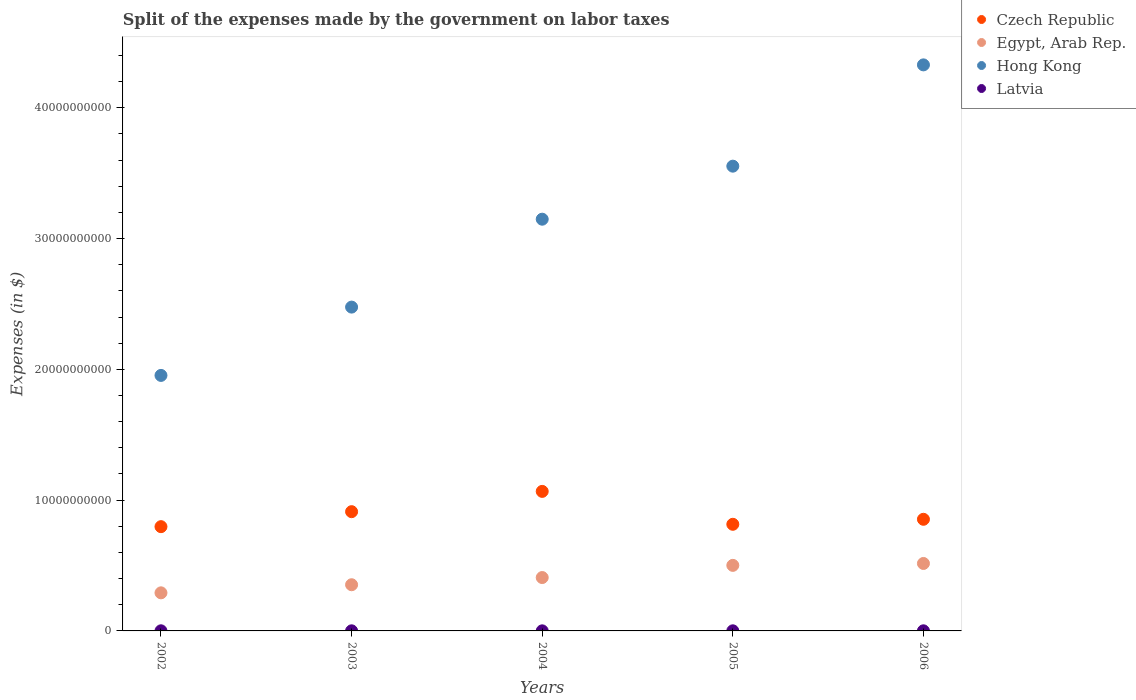What is the expenses made by the government on labor taxes in Egypt, Arab Rep. in 2005?
Give a very brief answer. 5.01e+09. Across all years, what is the maximum expenses made by the government on labor taxes in Czech Republic?
Make the answer very short. 1.07e+1. Across all years, what is the minimum expenses made by the government on labor taxes in Czech Republic?
Your answer should be very brief. 7.97e+09. In which year was the expenses made by the government on labor taxes in Latvia maximum?
Your answer should be very brief. 2002. In which year was the expenses made by the government on labor taxes in Hong Kong minimum?
Your response must be concise. 2002. What is the total expenses made by the government on labor taxes in Czech Republic in the graph?
Offer a very short reply. 4.44e+1. What is the difference between the expenses made by the government on labor taxes in Latvia in 2002 and the expenses made by the government on labor taxes in Egypt, Arab Rep. in 2005?
Your answer should be compact. -5.00e+09. What is the average expenses made by the government on labor taxes in Egypt, Arab Rep. per year?
Give a very brief answer. 4.14e+09. In the year 2002, what is the difference between the expenses made by the government on labor taxes in Czech Republic and expenses made by the government on labor taxes in Latvia?
Provide a succinct answer. 7.96e+09. In how many years, is the expenses made by the government on labor taxes in Egypt, Arab Rep. greater than 22000000000 $?
Give a very brief answer. 0. What is the ratio of the expenses made by the government on labor taxes in Latvia in 2003 to that in 2004?
Offer a very short reply. 1.28. Is the expenses made by the government on labor taxes in Latvia in 2004 less than that in 2006?
Your answer should be very brief. Yes. What is the difference between the highest and the second highest expenses made by the government on labor taxes in Czech Republic?
Make the answer very short. 1.55e+09. What is the difference between the highest and the lowest expenses made by the government on labor taxes in Latvia?
Offer a terse response. 2.50e+06. In how many years, is the expenses made by the government on labor taxes in Latvia greater than the average expenses made by the government on labor taxes in Latvia taken over all years?
Offer a terse response. 3. Is the sum of the expenses made by the government on labor taxes in Czech Republic in 2003 and 2005 greater than the maximum expenses made by the government on labor taxes in Hong Kong across all years?
Offer a terse response. No. Is it the case that in every year, the sum of the expenses made by the government on labor taxes in Czech Republic and expenses made by the government on labor taxes in Latvia  is greater than the sum of expenses made by the government on labor taxes in Hong Kong and expenses made by the government on labor taxes in Egypt, Arab Rep.?
Your answer should be very brief. Yes. Is it the case that in every year, the sum of the expenses made by the government on labor taxes in Czech Republic and expenses made by the government on labor taxes in Hong Kong  is greater than the expenses made by the government on labor taxes in Egypt, Arab Rep.?
Keep it short and to the point. Yes. Does the expenses made by the government on labor taxes in Egypt, Arab Rep. monotonically increase over the years?
Make the answer very short. Yes. How many dotlines are there?
Offer a very short reply. 4. How many years are there in the graph?
Give a very brief answer. 5. What is the difference between two consecutive major ticks on the Y-axis?
Offer a terse response. 1.00e+1. Does the graph contain any zero values?
Keep it short and to the point. No. Does the graph contain grids?
Provide a short and direct response. No. How are the legend labels stacked?
Your answer should be compact. Vertical. What is the title of the graph?
Offer a terse response. Split of the expenses made by the government on labor taxes. Does "Gabon" appear as one of the legend labels in the graph?
Provide a short and direct response. No. What is the label or title of the Y-axis?
Offer a very short reply. Expenses (in $). What is the Expenses (in $) in Czech Republic in 2002?
Offer a terse response. 7.97e+09. What is the Expenses (in $) in Egypt, Arab Rep. in 2002?
Provide a short and direct response. 2.91e+09. What is the Expenses (in $) of Hong Kong in 2002?
Offer a very short reply. 1.95e+1. What is the Expenses (in $) of Latvia in 2002?
Your answer should be very brief. 8.60e+06. What is the Expenses (in $) in Czech Republic in 2003?
Your answer should be very brief. 9.12e+09. What is the Expenses (in $) in Egypt, Arab Rep. in 2003?
Provide a succinct answer. 3.53e+09. What is the Expenses (in $) of Hong Kong in 2003?
Your response must be concise. 2.48e+1. What is the Expenses (in $) in Latvia in 2003?
Give a very brief answer. 7.80e+06. What is the Expenses (in $) in Czech Republic in 2004?
Your answer should be compact. 1.07e+1. What is the Expenses (in $) of Egypt, Arab Rep. in 2004?
Your response must be concise. 4.08e+09. What is the Expenses (in $) of Hong Kong in 2004?
Your response must be concise. 3.15e+1. What is the Expenses (in $) of Latvia in 2004?
Your response must be concise. 6.10e+06. What is the Expenses (in $) in Czech Republic in 2005?
Provide a short and direct response. 8.15e+09. What is the Expenses (in $) of Egypt, Arab Rep. in 2005?
Ensure brevity in your answer.  5.01e+09. What is the Expenses (in $) of Hong Kong in 2005?
Provide a short and direct response. 3.55e+1. What is the Expenses (in $) in Latvia in 2005?
Give a very brief answer. 8.10e+06. What is the Expenses (in $) in Czech Republic in 2006?
Make the answer very short. 8.54e+09. What is the Expenses (in $) of Egypt, Arab Rep. in 2006?
Keep it short and to the point. 5.16e+09. What is the Expenses (in $) of Hong Kong in 2006?
Your answer should be very brief. 4.33e+1. What is the Expenses (in $) in Latvia in 2006?
Your answer should be compact. 8.40e+06. Across all years, what is the maximum Expenses (in $) of Czech Republic?
Provide a succinct answer. 1.07e+1. Across all years, what is the maximum Expenses (in $) of Egypt, Arab Rep.?
Offer a terse response. 5.16e+09. Across all years, what is the maximum Expenses (in $) in Hong Kong?
Ensure brevity in your answer.  4.33e+1. Across all years, what is the maximum Expenses (in $) in Latvia?
Keep it short and to the point. 8.60e+06. Across all years, what is the minimum Expenses (in $) in Czech Republic?
Keep it short and to the point. 7.97e+09. Across all years, what is the minimum Expenses (in $) in Egypt, Arab Rep.?
Offer a very short reply. 2.91e+09. Across all years, what is the minimum Expenses (in $) of Hong Kong?
Provide a short and direct response. 1.95e+1. Across all years, what is the minimum Expenses (in $) of Latvia?
Offer a very short reply. 6.10e+06. What is the total Expenses (in $) of Czech Republic in the graph?
Give a very brief answer. 4.44e+1. What is the total Expenses (in $) in Egypt, Arab Rep. in the graph?
Offer a terse response. 2.07e+1. What is the total Expenses (in $) of Hong Kong in the graph?
Provide a short and direct response. 1.55e+11. What is the total Expenses (in $) in Latvia in the graph?
Offer a very short reply. 3.90e+07. What is the difference between the Expenses (in $) of Czech Republic in 2002 and that in 2003?
Give a very brief answer. -1.15e+09. What is the difference between the Expenses (in $) of Egypt, Arab Rep. in 2002 and that in 2003?
Ensure brevity in your answer.  -6.19e+08. What is the difference between the Expenses (in $) of Hong Kong in 2002 and that in 2003?
Give a very brief answer. -5.22e+09. What is the difference between the Expenses (in $) of Latvia in 2002 and that in 2003?
Make the answer very short. 8.00e+05. What is the difference between the Expenses (in $) in Czech Republic in 2002 and that in 2004?
Ensure brevity in your answer.  -2.70e+09. What is the difference between the Expenses (in $) of Egypt, Arab Rep. in 2002 and that in 2004?
Keep it short and to the point. -1.17e+09. What is the difference between the Expenses (in $) in Hong Kong in 2002 and that in 2004?
Give a very brief answer. -1.19e+1. What is the difference between the Expenses (in $) of Latvia in 2002 and that in 2004?
Keep it short and to the point. 2.50e+06. What is the difference between the Expenses (in $) of Czech Republic in 2002 and that in 2005?
Keep it short and to the point. -1.81e+08. What is the difference between the Expenses (in $) in Egypt, Arab Rep. in 2002 and that in 2005?
Keep it short and to the point. -2.10e+09. What is the difference between the Expenses (in $) of Hong Kong in 2002 and that in 2005?
Give a very brief answer. -1.60e+1. What is the difference between the Expenses (in $) in Czech Republic in 2002 and that in 2006?
Your answer should be very brief. -5.64e+08. What is the difference between the Expenses (in $) of Egypt, Arab Rep. in 2002 and that in 2006?
Offer a very short reply. -2.25e+09. What is the difference between the Expenses (in $) of Hong Kong in 2002 and that in 2006?
Your response must be concise. -2.37e+1. What is the difference between the Expenses (in $) of Czech Republic in 2003 and that in 2004?
Ensure brevity in your answer.  -1.55e+09. What is the difference between the Expenses (in $) in Egypt, Arab Rep. in 2003 and that in 2004?
Your answer should be very brief. -5.50e+08. What is the difference between the Expenses (in $) of Hong Kong in 2003 and that in 2004?
Ensure brevity in your answer.  -6.72e+09. What is the difference between the Expenses (in $) of Latvia in 2003 and that in 2004?
Make the answer very short. 1.70e+06. What is the difference between the Expenses (in $) of Czech Republic in 2003 and that in 2005?
Give a very brief answer. 9.65e+08. What is the difference between the Expenses (in $) in Egypt, Arab Rep. in 2003 and that in 2005?
Give a very brief answer. -1.48e+09. What is the difference between the Expenses (in $) of Hong Kong in 2003 and that in 2005?
Give a very brief answer. -1.08e+1. What is the difference between the Expenses (in $) in Latvia in 2003 and that in 2005?
Provide a succinct answer. -3.00e+05. What is the difference between the Expenses (in $) of Czech Republic in 2003 and that in 2006?
Offer a very short reply. 5.82e+08. What is the difference between the Expenses (in $) in Egypt, Arab Rep. in 2003 and that in 2006?
Your answer should be compact. -1.63e+09. What is the difference between the Expenses (in $) in Hong Kong in 2003 and that in 2006?
Offer a very short reply. -1.85e+1. What is the difference between the Expenses (in $) of Latvia in 2003 and that in 2006?
Offer a very short reply. -6.00e+05. What is the difference between the Expenses (in $) of Czech Republic in 2004 and that in 2005?
Give a very brief answer. 2.52e+09. What is the difference between the Expenses (in $) of Egypt, Arab Rep. in 2004 and that in 2005?
Your answer should be compact. -9.31e+08. What is the difference between the Expenses (in $) in Hong Kong in 2004 and that in 2005?
Give a very brief answer. -4.06e+09. What is the difference between the Expenses (in $) of Czech Republic in 2004 and that in 2006?
Offer a terse response. 2.13e+09. What is the difference between the Expenses (in $) in Egypt, Arab Rep. in 2004 and that in 2006?
Give a very brief answer. -1.08e+09. What is the difference between the Expenses (in $) in Hong Kong in 2004 and that in 2006?
Your answer should be very brief. -1.18e+1. What is the difference between the Expenses (in $) in Latvia in 2004 and that in 2006?
Offer a terse response. -2.30e+06. What is the difference between the Expenses (in $) of Czech Republic in 2005 and that in 2006?
Make the answer very short. -3.83e+08. What is the difference between the Expenses (in $) in Egypt, Arab Rep. in 2005 and that in 2006?
Ensure brevity in your answer.  -1.46e+08. What is the difference between the Expenses (in $) of Hong Kong in 2005 and that in 2006?
Your answer should be very brief. -7.74e+09. What is the difference between the Expenses (in $) of Czech Republic in 2002 and the Expenses (in $) of Egypt, Arab Rep. in 2003?
Your response must be concise. 4.44e+09. What is the difference between the Expenses (in $) of Czech Republic in 2002 and the Expenses (in $) of Hong Kong in 2003?
Your answer should be compact. -1.68e+1. What is the difference between the Expenses (in $) of Czech Republic in 2002 and the Expenses (in $) of Latvia in 2003?
Provide a short and direct response. 7.96e+09. What is the difference between the Expenses (in $) in Egypt, Arab Rep. in 2002 and the Expenses (in $) in Hong Kong in 2003?
Make the answer very short. -2.18e+1. What is the difference between the Expenses (in $) of Egypt, Arab Rep. in 2002 and the Expenses (in $) of Latvia in 2003?
Ensure brevity in your answer.  2.90e+09. What is the difference between the Expenses (in $) in Hong Kong in 2002 and the Expenses (in $) in Latvia in 2003?
Ensure brevity in your answer.  1.95e+1. What is the difference between the Expenses (in $) in Czech Republic in 2002 and the Expenses (in $) in Egypt, Arab Rep. in 2004?
Provide a short and direct response. 3.89e+09. What is the difference between the Expenses (in $) of Czech Republic in 2002 and the Expenses (in $) of Hong Kong in 2004?
Your answer should be compact. -2.35e+1. What is the difference between the Expenses (in $) of Czech Republic in 2002 and the Expenses (in $) of Latvia in 2004?
Keep it short and to the point. 7.97e+09. What is the difference between the Expenses (in $) of Egypt, Arab Rep. in 2002 and the Expenses (in $) of Hong Kong in 2004?
Make the answer very short. -2.86e+1. What is the difference between the Expenses (in $) in Egypt, Arab Rep. in 2002 and the Expenses (in $) in Latvia in 2004?
Keep it short and to the point. 2.91e+09. What is the difference between the Expenses (in $) in Hong Kong in 2002 and the Expenses (in $) in Latvia in 2004?
Ensure brevity in your answer.  1.95e+1. What is the difference between the Expenses (in $) in Czech Republic in 2002 and the Expenses (in $) in Egypt, Arab Rep. in 2005?
Keep it short and to the point. 2.96e+09. What is the difference between the Expenses (in $) in Czech Republic in 2002 and the Expenses (in $) in Hong Kong in 2005?
Your answer should be compact. -2.76e+1. What is the difference between the Expenses (in $) in Czech Republic in 2002 and the Expenses (in $) in Latvia in 2005?
Offer a terse response. 7.96e+09. What is the difference between the Expenses (in $) in Egypt, Arab Rep. in 2002 and the Expenses (in $) in Hong Kong in 2005?
Give a very brief answer. -3.26e+1. What is the difference between the Expenses (in $) in Egypt, Arab Rep. in 2002 and the Expenses (in $) in Latvia in 2005?
Offer a very short reply. 2.90e+09. What is the difference between the Expenses (in $) in Hong Kong in 2002 and the Expenses (in $) in Latvia in 2005?
Your response must be concise. 1.95e+1. What is the difference between the Expenses (in $) in Czech Republic in 2002 and the Expenses (in $) in Egypt, Arab Rep. in 2006?
Provide a succinct answer. 2.81e+09. What is the difference between the Expenses (in $) of Czech Republic in 2002 and the Expenses (in $) of Hong Kong in 2006?
Provide a short and direct response. -3.53e+1. What is the difference between the Expenses (in $) of Czech Republic in 2002 and the Expenses (in $) of Latvia in 2006?
Provide a short and direct response. 7.96e+09. What is the difference between the Expenses (in $) of Egypt, Arab Rep. in 2002 and the Expenses (in $) of Hong Kong in 2006?
Ensure brevity in your answer.  -4.04e+1. What is the difference between the Expenses (in $) of Egypt, Arab Rep. in 2002 and the Expenses (in $) of Latvia in 2006?
Make the answer very short. 2.90e+09. What is the difference between the Expenses (in $) in Hong Kong in 2002 and the Expenses (in $) in Latvia in 2006?
Offer a very short reply. 1.95e+1. What is the difference between the Expenses (in $) in Czech Republic in 2003 and the Expenses (in $) in Egypt, Arab Rep. in 2004?
Offer a very short reply. 5.04e+09. What is the difference between the Expenses (in $) of Czech Republic in 2003 and the Expenses (in $) of Hong Kong in 2004?
Provide a succinct answer. -2.24e+1. What is the difference between the Expenses (in $) of Czech Republic in 2003 and the Expenses (in $) of Latvia in 2004?
Give a very brief answer. 9.11e+09. What is the difference between the Expenses (in $) of Egypt, Arab Rep. in 2003 and the Expenses (in $) of Hong Kong in 2004?
Your response must be concise. -2.80e+1. What is the difference between the Expenses (in $) in Egypt, Arab Rep. in 2003 and the Expenses (in $) in Latvia in 2004?
Your response must be concise. 3.52e+09. What is the difference between the Expenses (in $) of Hong Kong in 2003 and the Expenses (in $) of Latvia in 2004?
Your answer should be compact. 2.48e+1. What is the difference between the Expenses (in $) of Czech Republic in 2003 and the Expenses (in $) of Egypt, Arab Rep. in 2005?
Offer a terse response. 4.11e+09. What is the difference between the Expenses (in $) in Czech Republic in 2003 and the Expenses (in $) in Hong Kong in 2005?
Ensure brevity in your answer.  -2.64e+1. What is the difference between the Expenses (in $) in Czech Republic in 2003 and the Expenses (in $) in Latvia in 2005?
Offer a very short reply. 9.11e+09. What is the difference between the Expenses (in $) of Egypt, Arab Rep. in 2003 and the Expenses (in $) of Hong Kong in 2005?
Provide a succinct answer. -3.20e+1. What is the difference between the Expenses (in $) of Egypt, Arab Rep. in 2003 and the Expenses (in $) of Latvia in 2005?
Make the answer very short. 3.52e+09. What is the difference between the Expenses (in $) in Hong Kong in 2003 and the Expenses (in $) in Latvia in 2005?
Keep it short and to the point. 2.48e+1. What is the difference between the Expenses (in $) in Czech Republic in 2003 and the Expenses (in $) in Egypt, Arab Rep. in 2006?
Your answer should be compact. 3.96e+09. What is the difference between the Expenses (in $) in Czech Republic in 2003 and the Expenses (in $) in Hong Kong in 2006?
Offer a very short reply. -3.42e+1. What is the difference between the Expenses (in $) in Czech Republic in 2003 and the Expenses (in $) in Latvia in 2006?
Your answer should be compact. 9.11e+09. What is the difference between the Expenses (in $) of Egypt, Arab Rep. in 2003 and the Expenses (in $) of Hong Kong in 2006?
Offer a terse response. -3.98e+1. What is the difference between the Expenses (in $) in Egypt, Arab Rep. in 2003 and the Expenses (in $) in Latvia in 2006?
Your answer should be compact. 3.52e+09. What is the difference between the Expenses (in $) in Hong Kong in 2003 and the Expenses (in $) in Latvia in 2006?
Your response must be concise. 2.48e+1. What is the difference between the Expenses (in $) of Czech Republic in 2004 and the Expenses (in $) of Egypt, Arab Rep. in 2005?
Provide a succinct answer. 5.66e+09. What is the difference between the Expenses (in $) in Czech Republic in 2004 and the Expenses (in $) in Hong Kong in 2005?
Provide a short and direct response. -2.49e+1. What is the difference between the Expenses (in $) of Czech Republic in 2004 and the Expenses (in $) of Latvia in 2005?
Your answer should be very brief. 1.07e+1. What is the difference between the Expenses (in $) in Egypt, Arab Rep. in 2004 and the Expenses (in $) in Hong Kong in 2005?
Provide a succinct answer. -3.15e+1. What is the difference between the Expenses (in $) of Egypt, Arab Rep. in 2004 and the Expenses (in $) of Latvia in 2005?
Keep it short and to the point. 4.07e+09. What is the difference between the Expenses (in $) of Hong Kong in 2004 and the Expenses (in $) of Latvia in 2005?
Your answer should be compact. 3.15e+1. What is the difference between the Expenses (in $) of Czech Republic in 2004 and the Expenses (in $) of Egypt, Arab Rep. in 2006?
Ensure brevity in your answer.  5.51e+09. What is the difference between the Expenses (in $) of Czech Republic in 2004 and the Expenses (in $) of Hong Kong in 2006?
Your answer should be very brief. -3.26e+1. What is the difference between the Expenses (in $) of Czech Republic in 2004 and the Expenses (in $) of Latvia in 2006?
Offer a very short reply. 1.07e+1. What is the difference between the Expenses (in $) in Egypt, Arab Rep. in 2004 and the Expenses (in $) in Hong Kong in 2006?
Provide a succinct answer. -3.92e+1. What is the difference between the Expenses (in $) in Egypt, Arab Rep. in 2004 and the Expenses (in $) in Latvia in 2006?
Provide a short and direct response. 4.07e+09. What is the difference between the Expenses (in $) of Hong Kong in 2004 and the Expenses (in $) of Latvia in 2006?
Your response must be concise. 3.15e+1. What is the difference between the Expenses (in $) in Czech Republic in 2005 and the Expenses (in $) in Egypt, Arab Rep. in 2006?
Offer a very short reply. 3.00e+09. What is the difference between the Expenses (in $) of Czech Republic in 2005 and the Expenses (in $) of Hong Kong in 2006?
Offer a terse response. -3.51e+1. What is the difference between the Expenses (in $) in Czech Republic in 2005 and the Expenses (in $) in Latvia in 2006?
Keep it short and to the point. 8.14e+09. What is the difference between the Expenses (in $) in Egypt, Arab Rep. in 2005 and the Expenses (in $) in Hong Kong in 2006?
Provide a short and direct response. -3.83e+1. What is the difference between the Expenses (in $) in Egypt, Arab Rep. in 2005 and the Expenses (in $) in Latvia in 2006?
Provide a succinct answer. 5.00e+09. What is the difference between the Expenses (in $) in Hong Kong in 2005 and the Expenses (in $) in Latvia in 2006?
Ensure brevity in your answer.  3.55e+1. What is the average Expenses (in $) in Czech Republic per year?
Offer a terse response. 8.89e+09. What is the average Expenses (in $) in Egypt, Arab Rep. per year?
Offer a very short reply. 4.14e+09. What is the average Expenses (in $) of Hong Kong per year?
Offer a very short reply. 3.09e+1. What is the average Expenses (in $) of Latvia per year?
Keep it short and to the point. 7.80e+06. In the year 2002, what is the difference between the Expenses (in $) of Czech Republic and Expenses (in $) of Egypt, Arab Rep.?
Offer a very short reply. 5.06e+09. In the year 2002, what is the difference between the Expenses (in $) of Czech Republic and Expenses (in $) of Hong Kong?
Provide a short and direct response. -1.16e+1. In the year 2002, what is the difference between the Expenses (in $) in Czech Republic and Expenses (in $) in Latvia?
Make the answer very short. 7.96e+09. In the year 2002, what is the difference between the Expenses (in $) in Egypt, Arab Rep. and Expenses (in $) in Hong Kong?
Provide a short and direct response. -1.66e+1. In the year 2002, what is the difference between the Expenses (in $) in Egypt, Arab Rep. and Expenses (in $) in Latvia?
Keep it short and to the point. 2.90e+09. In the year 2002, what is the difference between the Expenses (in $) of Hong Kong and Expenses (in $) of Latvia?
Provide a short and direct response. 1.95e+1. In the year 2003, what is the difference between the Expenses (in $) of Czech Republic and Expenses (in $) of Egypt, Arab Rep.?
Make the answer very short. 5.59e+09. In the year 2003, what is the difference between the Expenses (in $) in Czech Republic and Expenses (in $) in Hong Kong?
Provide a succinct answer. -1.56e+1. In the year 2003, what is the difference between the Expenses (in $) in Czech Republic and Expenses (in $) in Latvia?
Your answer should be very brief. 9.11e+09. In the year 2003, what is the difference between the Expenses (in $) of Egypt, Arab Rep. and Expenses (in $) of Hong Kong?
Offer a very short reply. -2.12e+1. In the year 2003, what is the difference between the Expenses (in $) of Egypt, Arab Rep. and Expenses (in $) of Latvia?
Provide a succinct answer. 3.52e+09. In the year 2003, what is the difference between the Expenses (in $) of Hong Kong and Expenses (in $) of Latvia?
Ensure brevity in your answer.  2.48e+1. In the year 2004, what is the difference between the Expenses (in $) in Czech Republic and Expenses (in $) in Egypt, Arab Rep.?
Provide a short and direct response. 6.59e+09. In the year 2004, what is the difference between the Expenses (in $) of Czech Republic and Expenses (in $) of Hong Kong?
Give a very brief answer. -2.08e+1. In the year 2004, what is the difference between the Expenses (in $) in Czech Republic and Expenses (in $) in Latvia?
Provide a short and direct response. 1.07e+1. In the year 2004, what is the difference between the Expenses (in $) in Egypt, Arab Rep. and Expenses (in $) in Hong Kong?
Keep it short and to the point. -2.74e+1. In the year 2004, what is the difference between the Expenses (in $) in Egypt, Arab Rep. and Expenses (in $) in Latvia?
Keep it short and to the point. 4.07e+09. In the year 2004, what is the difference between the Expenses (in $) of Hong Kong and Expenses (in $) of Latvia?
Ensure brevity in your answer.  3.15e+1. In the year 2005, what is the difference between the Expenses (in $) of Czech Republic and Expenses (in $) of Egypt, Arab Rep.?
Ensure brevity in your answer.  3.14e+09. In the year 2005, what is the difference between the Expenses (in $) of Czech Republic and Expenses (in $) of Hong Kong?
Keep it short and to the point. -2.74e+1. In the year 2005, what is the difference between the Expenses (in $) of Czech Republic and Expenses (in $) of Latvia?
Keep it short and to the point. 8.14e+09. In the year 2005, what is the difference between the Expenses (in $) of Egypt, Arab Rep. and Expenses (in $) of Hong Kong?
Provide a succinct answer. -3.05e+1. In the year 2005, what is the difference between the Expenses (in $) in Egypt, Arab Rep. and Expenses (in $) in Latvia?
Your response must be concise. 5.00e+09. In the year 2005, what is the difference between the Expenses (in $) in Hong Kong and Expenses (in $) in Latvia?
Give a very brief answer. 3.55e+1. In the year 2006, what is the difference between the Expenses (in $) of Czech Republic and Expenses (in $) of Egypt, Arab Rep.?
Provide a succinct answer. 3.38e+09. In the year 2006, what is the difference between the Expenses (in $) in Czech Republic and Expenses (in $) in Hong Kong?
Your answer should be compact. -3.47e+1. In the year 2006, what is the difference between the Expenses (in $) in Czech Republic and Expenses (in $) in Latvia?
Ensure brevity in your answer.  8.53e+09. In the year 2006, what is the difference between the Expenses (in $) in Egypt, Arab Rep. and Expenses (in $) in Hong Kong?
Keep it short and to the point. -3.81e+1. In the year 2006, what is the difference between the Expenses (in $) of Egypt, Arab Rep. and Expenses (in $) of Latvia?
Offer a terse response. 5.15e+09. In the year 2006, what is the difference between the Expenses (in $) of Hong Kong and Expenses (in $) of Latvia?
Keep it short and to the point. 4.33e+1. What is the ratio of the Expenses (in $) of Czech Republic in 2002 to that in 2003?
Make the answer very short. 0.87. What is the ratio of the Expenses (in $) in Egypt, Arab Rep. in 2002 to that in 2003?
Your answer should be compact. 0.82. What is the ratio of the Expenses (in $) of Hong Kong in 2002 to that in 2003?
Keep it short and to the point. 0.79. What is the ratio of the Expenses (in $) of Latvia in 2002 to that in 2003?
Give a very brief answer. 1.1. What is the ratio of the Expenses (in $) in Czech Republic in 2002 to that in 2004?
Your response must be concise. 0.75. What is the ratio of the Expenses (in $) in Egypt, Arab Rep. in 2002 to that in 2004?
Your answer should be compact. 0.71. What is the ratio of the Expenses (in $) in Hong Kong in 2002 to that in 2004?
Provide a succinct answer. 0.62. What is the ratio of the Expenses (in $) of Latvia in 2002 to that in 2004?
Your answer should be very brief. 1.41. What is the ratio of the Expenses (in $) in Czech Republic in 2002 to that in 2005?
Offer a very short reply. 0.98. What is the ratio of the Expenses (in $) of Egypt, Arab Rep. in 2002 to that in 2005?
Make the answer very short. 0.58. What is the ratio of the Expenses (in $) of Hong Kong in 2002 to that in 2005?
Make the answer very short. 0.55. What is the ratio of the Expenses (in $) in Latvia in 2002 to that in 2005?
Your response must be concise. 1.06. What is the ratio of the Expenses (in $) in Czech Republic in 2002 to that in 2006?
Keep it short and to the point. 0.93. What is the ratio of the Expenses (in $) of Egypt, Arab Rep. in 2002 to that in 2006?
Keep it short and to the point. 0.56. What is the ratio of the Expenses (in $) in Hong Kong in 2002 to that in 2006?
Your answer should be very brief. 0.45. What is the ratio of the Expenses (in $) in Latvia in 2002 to that in 2006?
Offer a very short reply. 1.02. What is the ratio of the Expenses (in $) of Czech Republic in 2003 to that in 2004?
Give a very brief answer. 0.85. What is the ratio of the Expenses (in $) in Egypt, Arab Rep. in 2003 to that in 2004?
Offer a terse response. 0.87. What is the ratio of the Expenses (in $) in Hong Kong in 2003 to that in 2004?
Give a very brief answer. 0.79. What is the ratio of the Expenses (in $) in Latvia in 2003 to that in 2004?
Ensure brevity in your answer.  1.28. What is the ratio of the Expenses (in $) in Czech Republic in 2003 to that in 2005?
Your answer should be very brief. 1.12. What is the ratio of the Expenses (in $) of Egypt, Arab Rep. in 2003 to that in 2005?
Ensure brevity in your answer.  0.7. What is the ratio of the Expenses (in $) of Hong Kong in 2003 to that in 2005?
Make the answer very short. 0.7. What is the ratio of the Expenses (in $) in Czech Republic in 2003 to that in 2006?
Provide a succinct answer. 1.07. What is the ratio of the Expenses (in $) of Egypt, Arab Rep. in 2003 to that in 2006?
Make the answer very short. 0.68. What is the ratio of the Expenses (in $) of Hong Kong in 2003 to that in 2006?
Keep it short and to the point. 0.57. What is the ratio of the Expenses (in $) of Czech Republic in 2004 to that in 2005?
Make the answer very short. 1.31. What is the ratio of the Expenses (in $) in Egypt, Arab Rep. in 2004 to that in 2005?
Provide a short and direct response. 0.81. What is the ratio of the Expenses (in $) of Hong Kong in 2004 to that in 2005?
Make the answer very short. 0.89. What is the ratio of the Expenses (in $) in Latvia in 2004 to that in 2005?
Offer a terse response. 0.75. What is the ratio of the Expenses (in $) in Czech Republic in 2004 to that in 2006?
Offer a terse response. 1.25. What is the ratio of the Expenses (in $) in Egypt, Arab Rep. in 2004 to that in 2006?
Give a very brief answer. 0.79. What is the ratio of the Expenses (in $) of Hong Kong in 2004 to that in 2006?
Provide a short and direct response. 0.73. What is the ratio of the Expenses (in $) in Latvia in 2004 to that in 2006?
Give a very brief answer. 0.73. What is the ratio of the Expenses (in $) in Czech Republic in 2005 to that in 2006?
Offer a very short reply. 0.96. What is the ratio of the Expenses (in $) of Egypt, Arab Rep. in 2005 to that in 2006?
Offer a terse response. 0.97. What is the ratio of the Expenses (in $) in Hong Kong in 2005 to that in 2006?
Offer a terse response. 0.82. What is the ratio of the Expenses (in $) in Latvia in 2005 to that in 2006?
Offer a terse response. 0.96. What is the difference between the highest and the second highest Expenses (in $) in Czech Republic?
Offer a very short reply. 1.55e+09. What is the difference between the highest and the second highest Expenses (in $) in Egypt, Arab Rep.?
Make the answer very short. 1.46e+08. What is the difference between the highest and the second highest Expenses (in $) of Hong Kong?
Your response must be concise. 7.74e+09. What is the difference between the highest and the lowest Expenses (in $) of Czech Republic?
Make the answer very short. 2.70e+09. What is the difference between the highest and the lowest Expenses (in $) in Egypt, Arab Rep.?
Provide a succinct answer. 2.25e+09. What is the difference between the highest and the lowest Expenses (in $) in Hong Kong?
Provide a short and direct response. 2.37e+1. What is the difference between the highest and the lowest Expenses (in $) of Latvia?
Provide a short and direct response. 2.50e+06. 